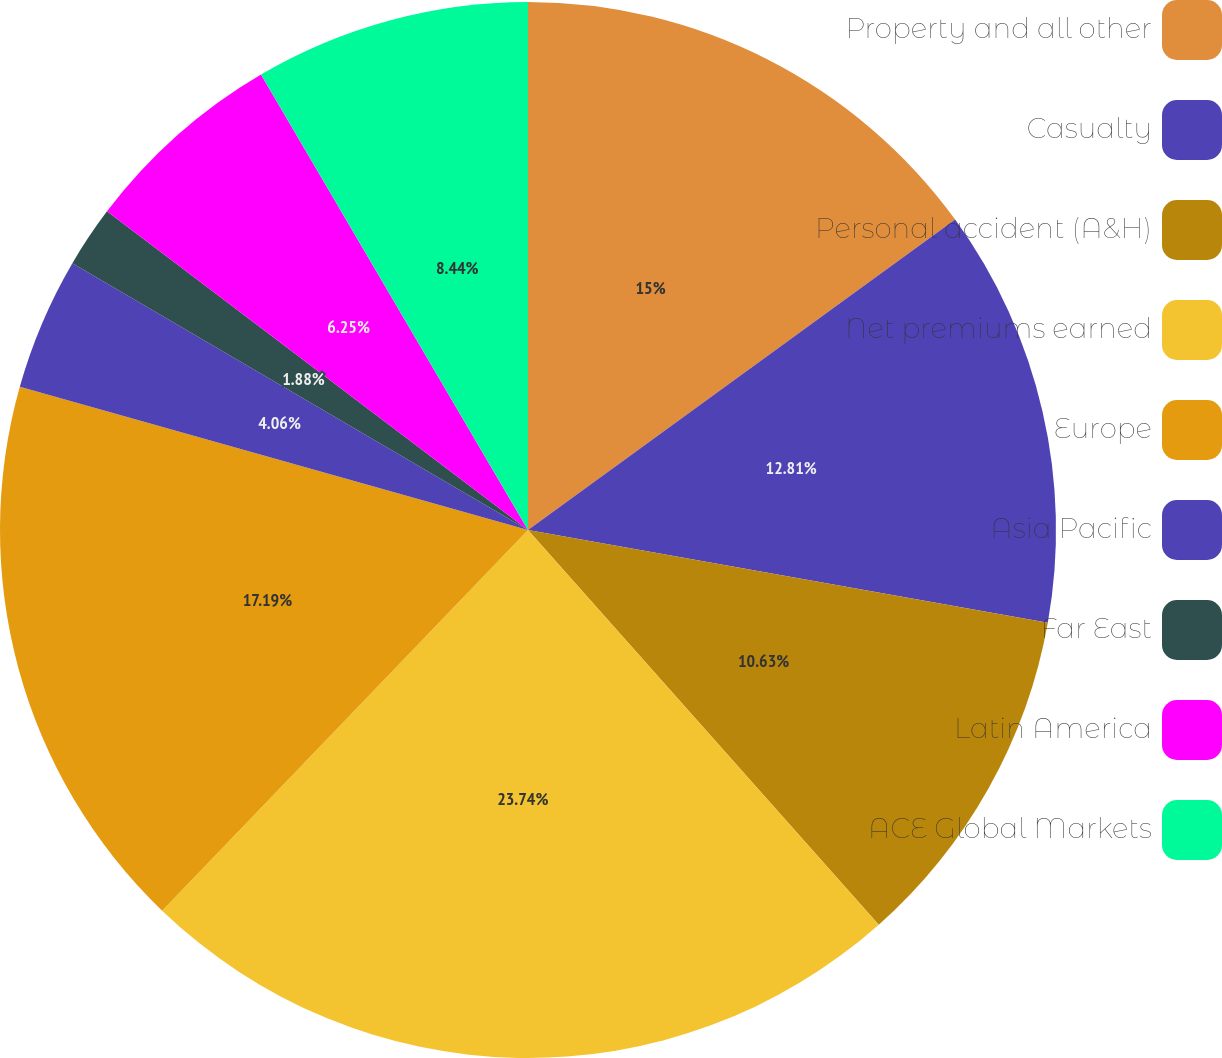Convert chart. <chart><loc_0><loc_0><loc_500><loc_500><pie_chart><fcel>Property and all other<fcel>Casualty<fcel>Personal accident (A&H)<fcel>Net premiums earned<fcel>Europe<fcel>Asia Pacific<fcel>Far East<fcel>Latin America<fcel>ACE Global Markets<nl><fcel>15.0%<fcel>12.81%<fcel>10.63%<fcel>23.75%<fcel>17.19%<fcel>4.06%<fcel>1.88%<fcel>6.25%<fcel>8.44%<nl></chart> 